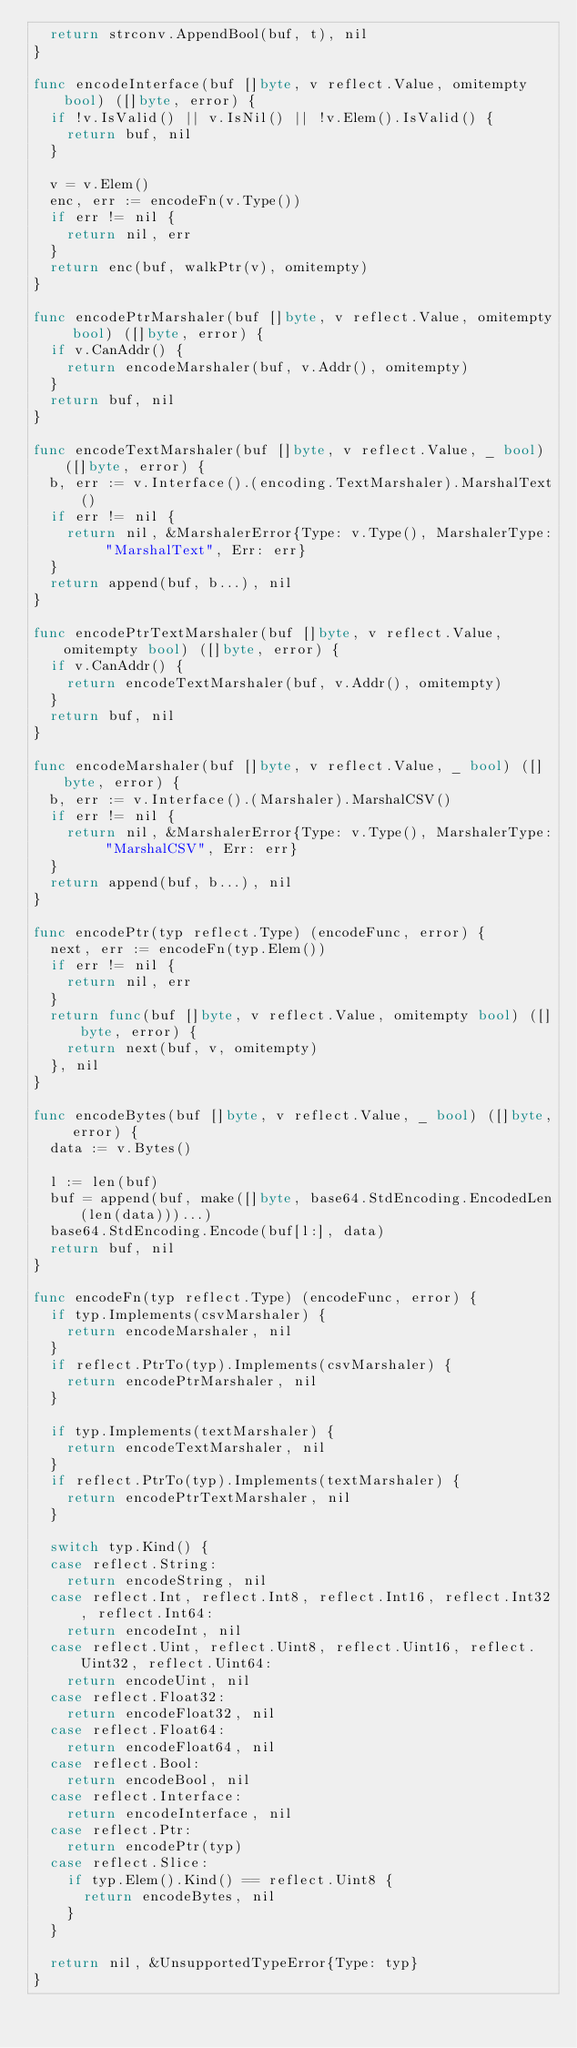Convert code to text. <code><loc_0><loc_0><loc_500><loc_500><_Go_>	return strconv.AppendBool(buf, t), nil
}

func encodeInterface(buf []byte, v reflect.Value, omitempty bool) ([]byte, error) {
	if !v.IsValid() || v.IsNil() || !v.Elem().IsValid() {
		return buf, nil
	}

	v = v.Elem()
	enc, err := encodeFn(v.Type())
	if err != nil {
		return nil, err
	}
	return enc(buf, walkPtr(v), omitempty)
}

func encodePtrMarshaler(buf []byte, v reflect.Value, omitempty bool) ([]byte, error) {
	if v.CanAddr() {
		return encodeMarshaler(buf, v.Addr(), omitempty)
	}
	return buf, nil
}

func encodeTextMarshaler(buf []byte, v reflect.Value, _ bool) ([]byte, error) {
	b, err := v.Interface().(encoding.TextMarshaler).MarshalText()
	if err != nil {
		return nil, &MarshalerError{Type: v.Type(), MarshalerType: "MarshalText", Err: err}
	}
	return append(buf, b...), nil
}

func encodePtrTextMarshaler(buf []byte, v reflect.Value, omitempty bool) ([]byte, error) {
	if v.CanAddr() {
		return encodeTextMarshaler(buf, v.Addr(), omitempty)
	}
	return buf, nil
}

func encodeMarshaler(buf []byte, v reflect.Value, _ bool) ([]byte, error) {
	b, err := v.Interface().(Marshaler).MarshalCSV()
	if err != nil {
		return nil, &MarshalerError{Type: v.Type(), MarshalerType: "MarshalCSV", Err: err}
	}
	return append(buf, b...), nil
}

func encodePtr(typ reflect.Type) (encodeFunc, error) {
	next, err := encodeFn(typ.Elem())
	if err != nil {
		return nil, err
	}
	return func(buf []byte, v reflect.Value, omitempty bool) ([]byte, error) {
		return next(buf, v, omitempty)
	}, nil
}

func encodeBytes(buf []byte, v reflect.Value, _ bool) ([]byte, error) {
	data := v.Bytes()

	l := len(buf)
	buf = append(buf, make([]byte, base64.StdEncoding.EncodedLen(len(data)))...)
	base64.StdEncoding.Encode(buf[l:], data)
	return buf, nil
}

func encodeFn(typ reflect.Type) (encodeFunc, error) {
	if typ.Implements(csvMarshaler) {
		return encodeMarshaler, nil
	}
	if reflect.PtrTo(typ).Implements(csvMarshaler) {
		return encodePtrMarshaler, nil
	}

	if typ.Implements(textMarshaler) {
		return encodeTextMarshaler, nil
	}
	if reflect.PtrTo(typ).Implements(textMarshaler) {
		return encodePtrTextMarshaler, nil
	}

	switch typ.Kind() {
	case reflect.String:
		return encodeString, nil
	case reflect.Int, reflect.Int8, reflect.Int16, reflect.Int32, reflect.Int64:
		return encodeInt, nil
	case reflect.Uint, reflect.Uint8, reflect.Uint16, reflect.Uint32, reflect.Uint64:
		return encodeUint, nil
	case reflect.Float32:
		return encodeFloat32, nil
	case reflect.Float64:
		return encodeFloat64, nil
	case reflect.Bool:
		return encodeBool, nil
	case reflect.Interface:
		return encodeInterface, nil
	case reflect.Ptr:
		return encodePtr(typ)
	case reflect.Slice:
		if typ.Elem().Kind() == reflect.Uint8 {
			return encodeBytes, nil
		}
	}

	return nil, &UnsupportedTypeError{Type: typ}
}
</code> 